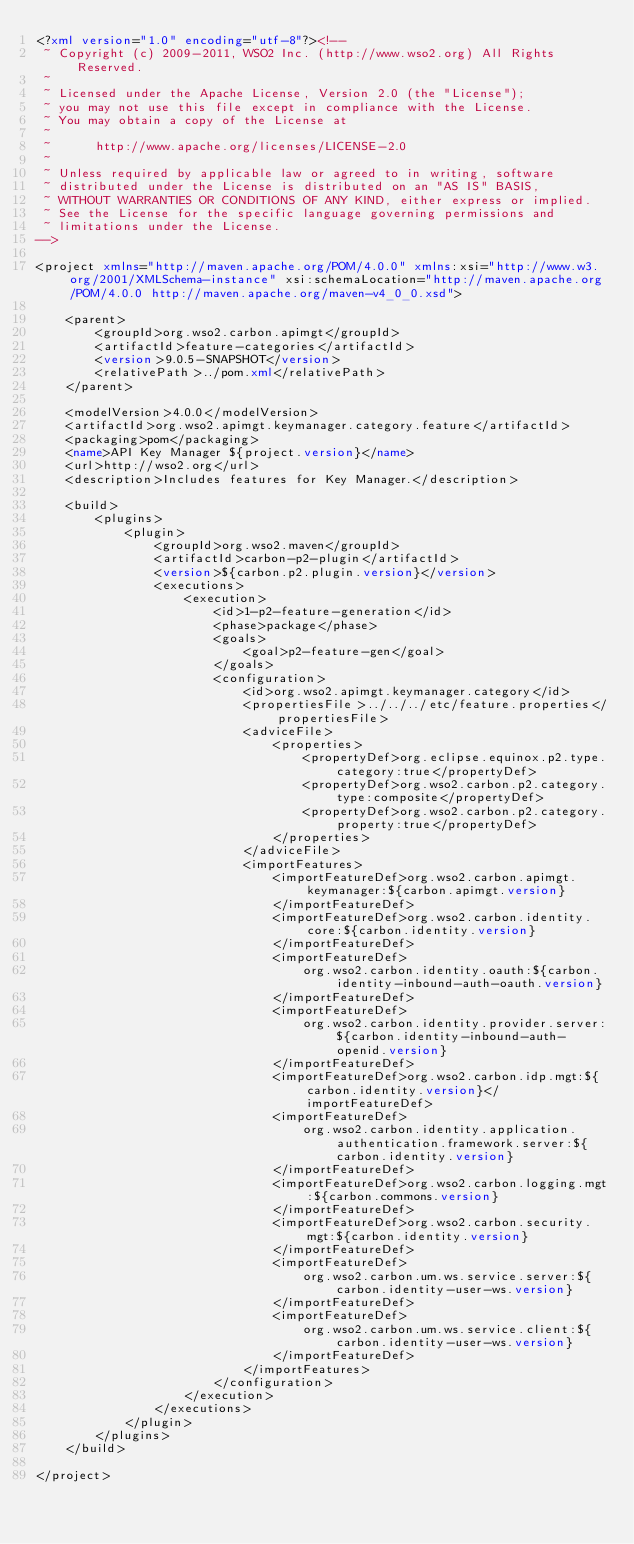<code> <loc_0><loc_0><loc_500><loc_500><_XML_><?xml version="1.0" encoding="utf-8"?><!--
 ~ Copyright (c) 2009-2011, WSO2 Inc. (http://www.wso2.org) All Rights Reserved.
 ~
 ~ Licensed under the Apache License, Version 2.0 (the "License");
 ~ you may not use this file except in compliance with the License.
 ~ You may obtain a copy of the License at
 ~
 ~      http://www.apache.org/licenses/LICENSE-2.0
 ~
 ~ Unless required by applicable law or agreed to in writing, software
 ~ distributed under the License is distributed on an "AS IS" BASIS,
 ~ WITHOUT WARRANTIES OR CONDITIONS OF ANY KIND, either express or implied.
 ~ See the License for the specific language governing permissions and
 ~ limitations under the License.
-->

<project xmlns="http://maven.apache.org/POM/4.0.0" xmlns:xsi="http://www.w3.org/2001/XMLSchema-instance" xsi:schemaLocation="http://maven.apache.org/POM/4.0.0 http://maven.apache.org/maven-v4_0_0.xsd">

    <parent>
        <groupId>org.wso2.carbon.apimgt</groupId>
        <artifactId>feature-categories</artifactId>
        <version>9.0.5-SNAPSHOT</version>
        <relativePath>../pom.xml</relativePath>
    </parent>

    <modelVersion>4.0.0</modelVersion>
    <artifactId>org.wso2.apimgt.keymanager.category.feature</artifactId>
    <packaging>pom</packaging>
    <name>API Key Manager ${project.version}</name>
    <url>http://wso2.org</url>
    <description>Includes features for Key Manager.</description>

    <build>
        <plugins>
            <plugin>
                <groupId>org.wso2.maven</groupId>
                <artifactId>carbon-p2-plugin</artifactId>
                <version>${carbon.p2.plugin.version}</version>
                <executions>
                    <execution>
                        <id>1-p2-feature-generation</id>
                        <phase>package</phase>
                        <goals>
                            <goal>p2-feature-gen</goal>
                        </goals>
                        <configuration>
                            <id>org.wso2.apimgt.keymanager.category</id>
                            <propertiesFile>../../../etc/feature.properties</propertiesFile>
                            <adviceFile>
                                <properties>
                                    <propertyDef>org.eclipse.equinox.p2.type.category:true</propertyDef>
                                    <propertyDef>org.wso2.carbon.p2.category.type:composite</propertyDef>
                                    <propertyDef>org.wso2.carbon.p2.category.property:true</propertyDef>
                                </properties>
                            </adviceFile>
                            <importFeatures>
                                <importFeatureDef>org.wso2.carbon.apimgt.keymanager:${carbon.apimgt.version}
                                </importFeatureDef>
                                <importFeatureDef>org.wso2.carbon.identity.core:${carbon.identity.version}
                                </importFeatureDef>
                                <importFeatureDef>
                                    org.wso2.carbon.identity.oauth:${carbon.identity-inbound-auth-oauth.version}
                                </importFeatureDef>
                                <importFeatureDef>
                                    org.wso2.carbon.identity.provider.server:${carbon.identity-inbound-auth-openid.version}
                                </importFeatureDef>
                                <importFeatureDef>org.wso2.carbon.idp.mgt:${carbon.identity.version}</importFeatureDef>
                                <importFeatureDef>
                                    org.wso2.carbon.identity.application.authentication.framework.server:${carbon.identity.version}
                                </importFeatureDef>
                                <importFeatureDef>org.wso2.carbon.logging.mgt:${carbon.commons.version}
                                </importFeatureDef>
                                <importFeatureDef>org.wso2.carbon.security.mgt:${carbon.identity.version}
                                </importFeatureDef>
                                <importFeatureDef>
                                    org.wso2.carbon.um.ws.service.server:${carbon.identity-user-ws.version}
                                </importFeatureDef>
                                <importFeatureDef>
                                    org.wso2.carbon.um.ws.service.client:${carbon.identity-user-ws.version}
                                </importFeatureDef>
                            </importFeatures>
                        </configuration>
                    </execution>
                </executions>
            </plugin>
        </plugins>
    </build>

</project>
</code> 